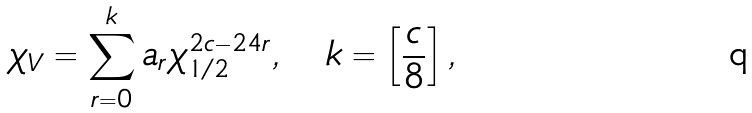<formula> <loc_0><loc_0><loc_500><loc_500>\chi _ { V } = \sum _ { r = 0 } ^ { k } a _ { r } \chi _ { 1 / 2 } ^ { 2 c - 2 4 r } , \quad k = \left [ \frac { c } { 8 } \right ] ,</formula> 